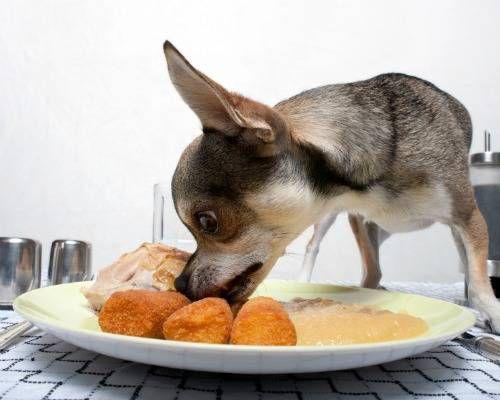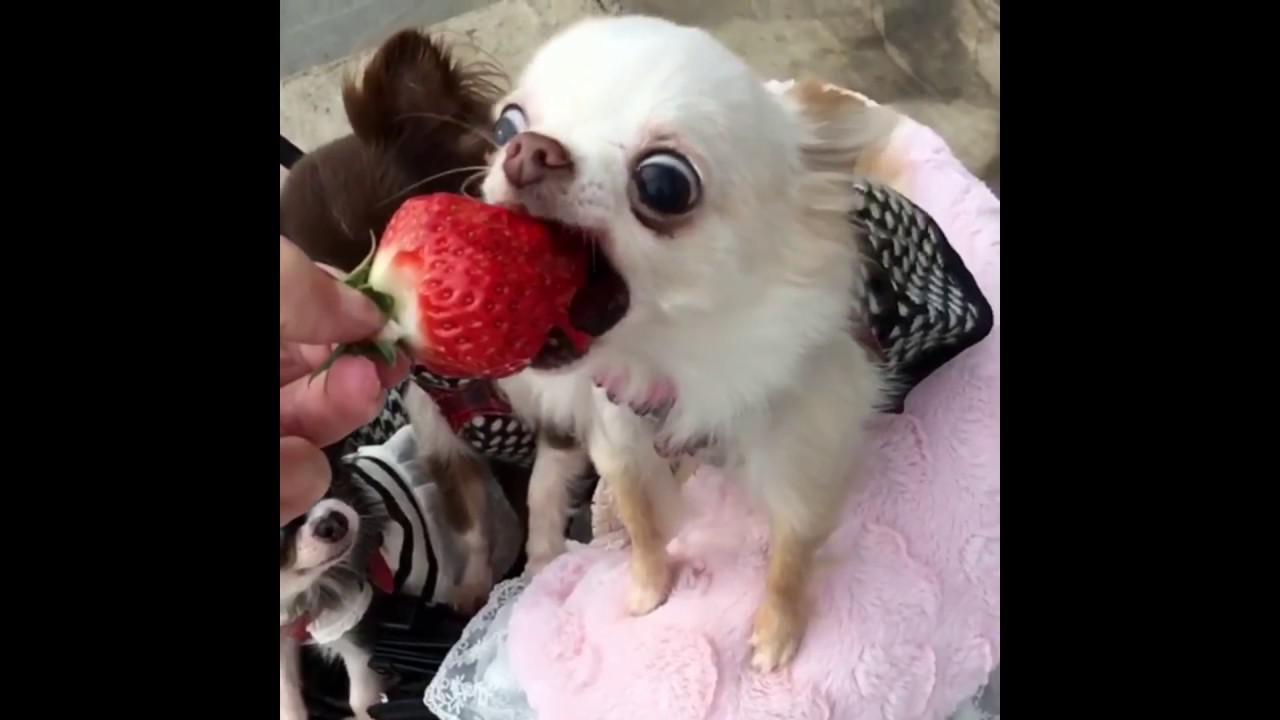The first image is the image on the left, the second image is the image on the right. Analyze the images presented: Is the assertion "One dog is eating strawberries." valid? Answer yes or no. Yes. The first image is the image on the left, the second image is the image on the right. For the images displayed, is the sentence "There is a dog standing beside a white plate full of food on a patterned table in one of the images." factually correct? Answer yes or no. Yes. 